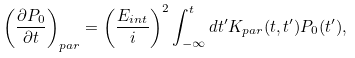<formula> <loc_0><loc_0><loc_500><loc_500>\left ( \frac { \partial { P _ { 0 } } } { \partial t } \right ) _ { p a r } = \left ( \frac { E _ { i n t } } { i } \right ) ^ { 2 } \int _ { - \infty } ^ { t } d t ^ { \prime } K _ { p a r } ( t , t ^ { \prime } ) P _ { 0 } ( t ^ { \prime } ) ,</formula> 